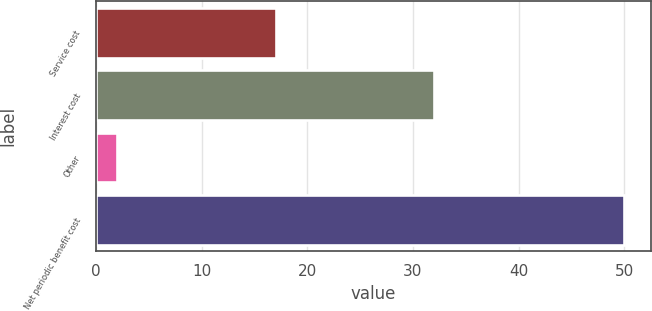Convert chart to OTSL. <chart><loc_0><loc_0><loc_500><loc_500><bar_chart><fcel>Service cost<fcel>Interest cost<fcel>Other<fcel>Net periodic benefit cost<nl><fcel>17<fcel>32<fcel>2<fcel>50<nl></chart> 